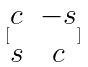Convert formula to latex. <formula><loc_0><loc_0><loc_500><loc_500>[ \begin{matrix} c & - s \\ s & c \end{matrix} ]</formula> 